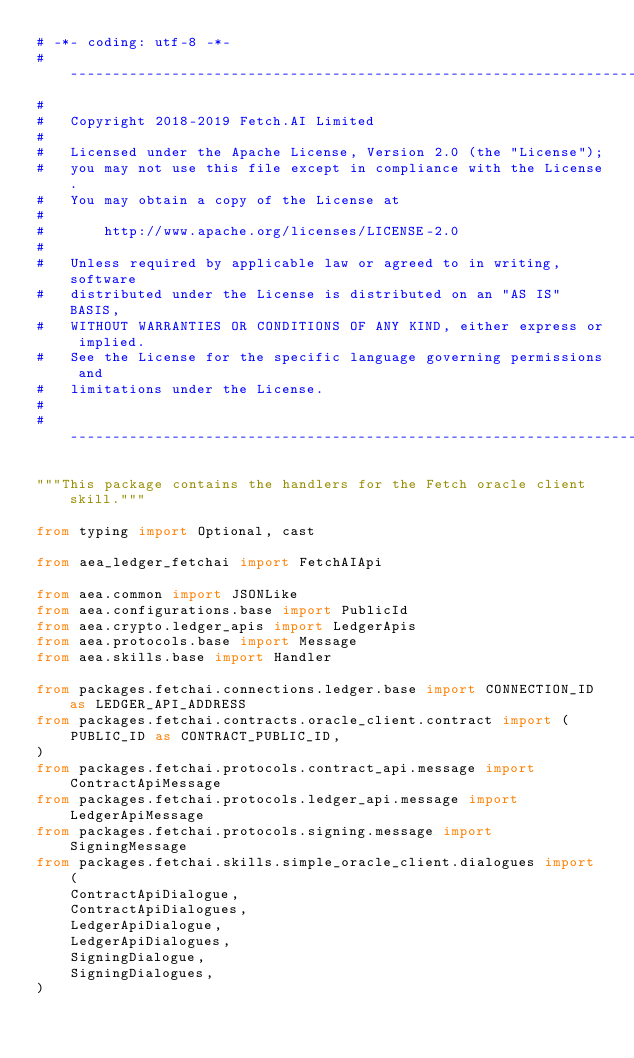<code> <loc_0><loc_0><loc_500><loc_500><_Python_># -*- coding: utf-8 -*-
# ------------------------------------------------------------------------------
#
#   Copyright 2018-2019 Fetch.AI Limited
#
#   Licensed under the Apache License, Version 2.0 (the "License");
#   you may not use this file except in compliance with the License.
#   You may obtain a copy of the License at
#
#       http://www.apache.org/licenses/LICENSE-2.0
#
#   Unless required by applicable law or agreed to in writing, software
#   distributed under the License is distributed on an "AS IS" BASIS,
#   WITHOUT WARRANTIES OR CONDITIONS OF ANY KIND, either express or implied.
#   See the License for the specific language governing permissions and
#   limitations under the License.
#
# ------------------------------------------------------------------------------

"""This package contains the handlers for the Fetch oracle client skill."""

from typing import Optional, cast

from aea_ledger_fetchai import FetchAIApi

from aea.common import JSONLike
from aea.configurations.base import PublicId
from aea.crypto.ledger_apis import LedgerApis
from aea.protocols.base import Message
from aea.skills.base import Handler

from packages.fetchai.connections.ledger.base import CONNECTION_ID as LEDGER_API_ADDRESS
from packages.fetchai.contracts.oracle_client.contract import (
    PUBLIC_ID as CONTRACT_PUBLIC_ID,
)
from packages.fetchai.protocols.contract_api.message import ContractApiMessage
from packages.fetchai.protocols.ledger_api.message import LedgerApiMessage
from packages.fetchai.protocols.signing.message import SigningMessage
from packages.fetchai.skills.simple_oracle_client.dialogues import (
    ContractApiDialogue,
    ContractApiDialogues,
    LedgerApiDialogue,
    LedgerApiDialogues,
    SigningDialogue,
    SigningDialogues,
)</code> 